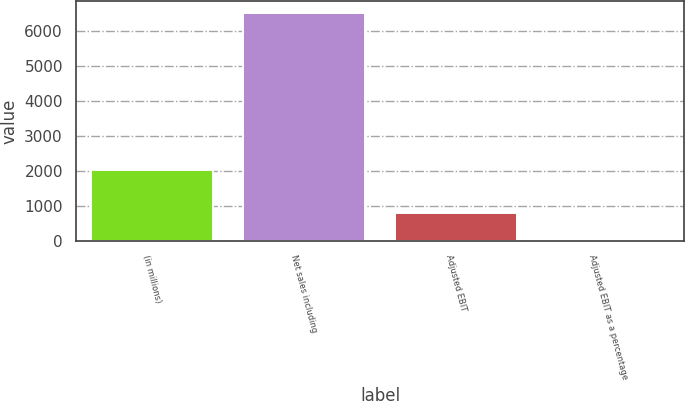Convert chart. <chart><loc_0><loc_0><loc_500><loc_500><bar_chart><fcel>(in millions)<fcel>Net sales including<fcel>Adjusted EBIT<fcel>Adjusted EBIT as a percentage<nl><fcel>2018<fcel>6534.6<fcel>801.3<fcel>12.3<nl></chart> 